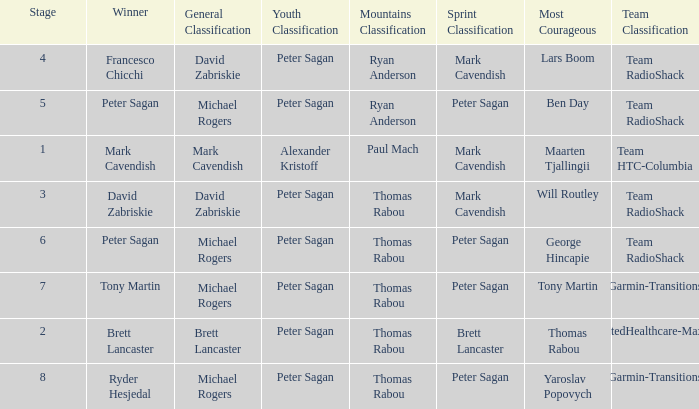When Peter Sagan won the youth classification and Thomas Rabou won the most corageous, who won the sprint classification? Brett Lancaster. 